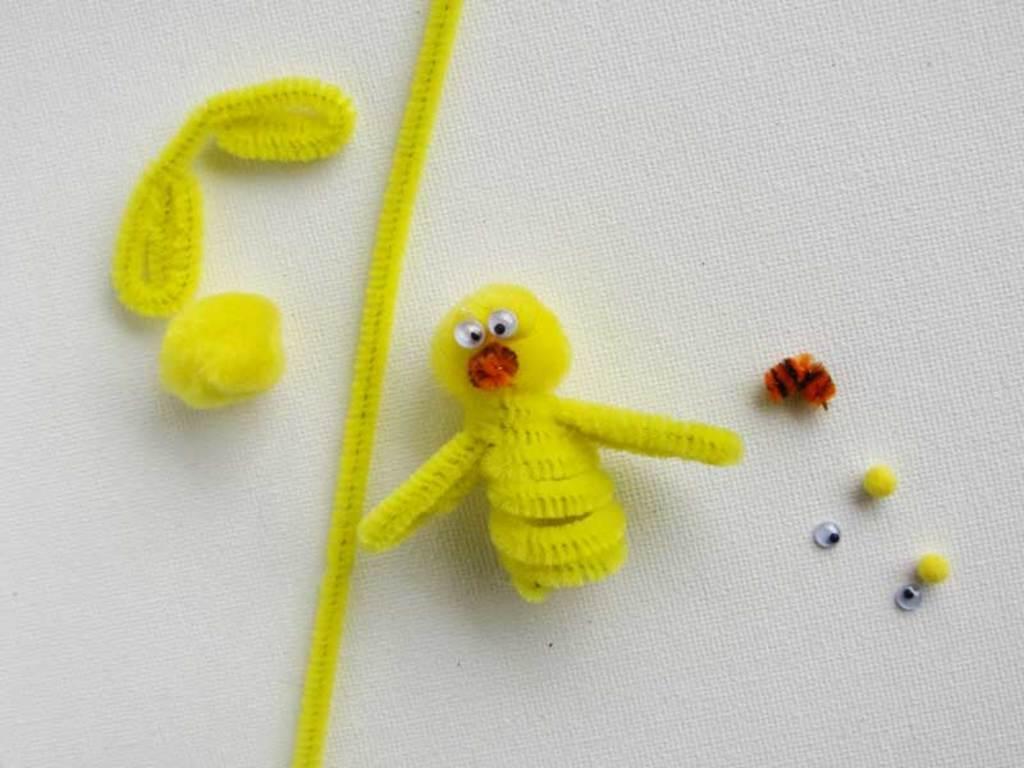Can you describe this image briefly? Here we can see craft on the white color cloth. 